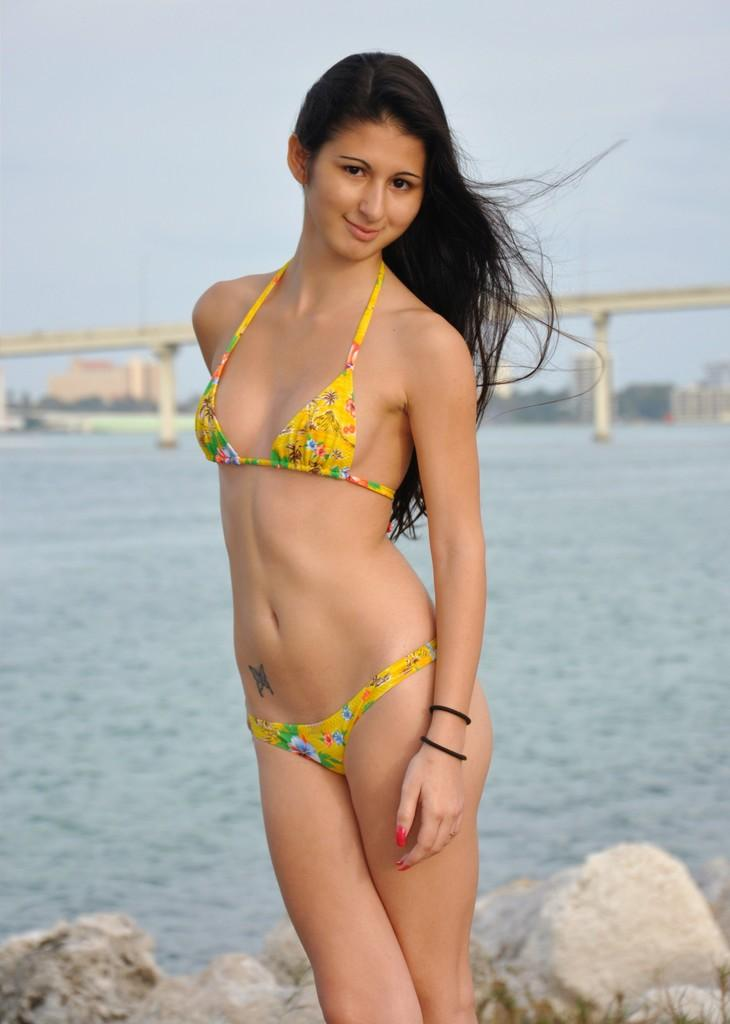What is the main subject of the image? There is a beautiful woman in the image. What is the woman wearing? The woman is wearing a yellow top and shorts. What is the woman's expression in the image? The woman is smiling. What can be seen in the background of the image? There is water visible in the image, as well as a bridge. What is visible at the top of the image? The sky is visible at the top of the image. What type of steam can be seen rising from the woman's clothes in the image? There is no steam present in the image; the woman is wearing a yellow top and shorts. What does the image smell like? The image does not have a smell, as it is a visual representation. 